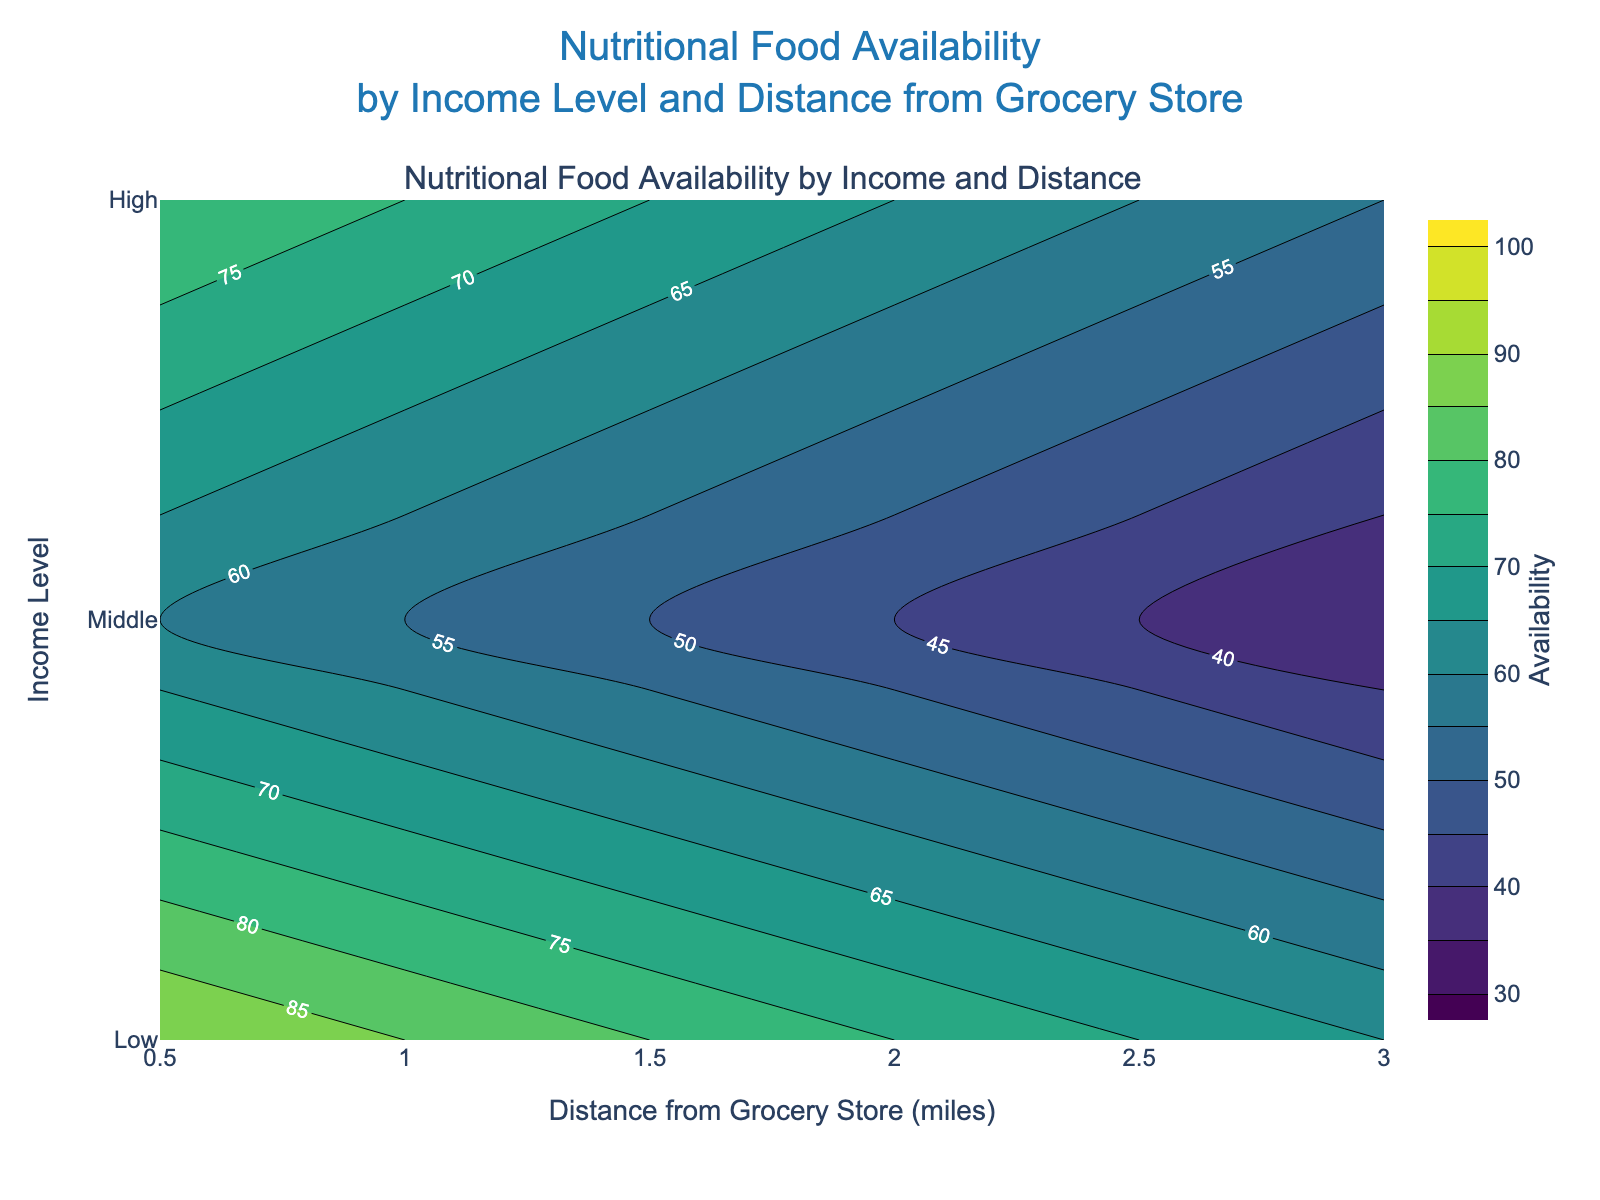What's the title of the plot? Look at the top of the plot where the title is positioned.
Answer: Nutritional Food Availability by Income Level and Distance from Grocery Store What are the colors used in the contour plot? Examine the range of colors within the plot, which typically form a gradient.
Answer: Various shades from the Viridis colorscale What's the distance range from the grocery store shown on the x-axis? Check the bottom x-axis for the starting and ending values.
Answer: 0.5 to 3.0 miles Which income level has the highest nutritional food availability at 1.5 miles distance? Trace the 1.5-mile mark on the x-axis upward to intersect with each income level, checking the contour values.
Answer: High Between which distances from the grocery store does the middle-income level experience a drop in nutritional food availability from 75 to 60? Trace the values for the middle-income level along the x-axis and note the distances where the contour values change from 75 to 60.
Answer: 1.0 to 2.5 miles At what distance from the grocery store does the low-income level have a nutritional food availability value of 40? Locate the contour line representing the value of 40 and trace it to where it intersects with the low-income level on the y-axis.
Answer: 2.5 miles How does the nutritional food availability change for the high-income level as the distance increases from 0.5 to 3.0 miles? Observe the contour lines or shades for the high-income level as the distance increases from 0.5 to 3.0 miles.
Answer: It decreases from 90 to 65 What is the average nutritional food availability for the middle-income level across all distances? List the availability values for the middle-income level (80, 75, 70, 65, 60, 55), sum them, and divide by the number of values.
Answer: (80 + 75 + 70 + 65 + 60 + 55) / 6 = 67.5 Which income level has the steepest decline in nutritional food availability over distance? Compare the differences in availability values from 0.5 to 3.0 miles for each income level to see which has the largest change.
Answer: Low Where is the contour value of 70 found for the high-income level in the plot? Follow the contour line matching the value of 70 and check where it aligns with the high-income level on the y-axis.
Answer: 2.5 miles 